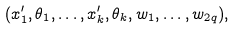<formula> <loc_0><loc_0><loc_500><loc_500>( x _ { 1 } ^ { \prime } , \theta _ { 1 } , \dots , x _ { k } ^ { \prime } , \theta _ { k } , w _ { 1 } , \dots , w _ { 2 q } ) ,</formula> 